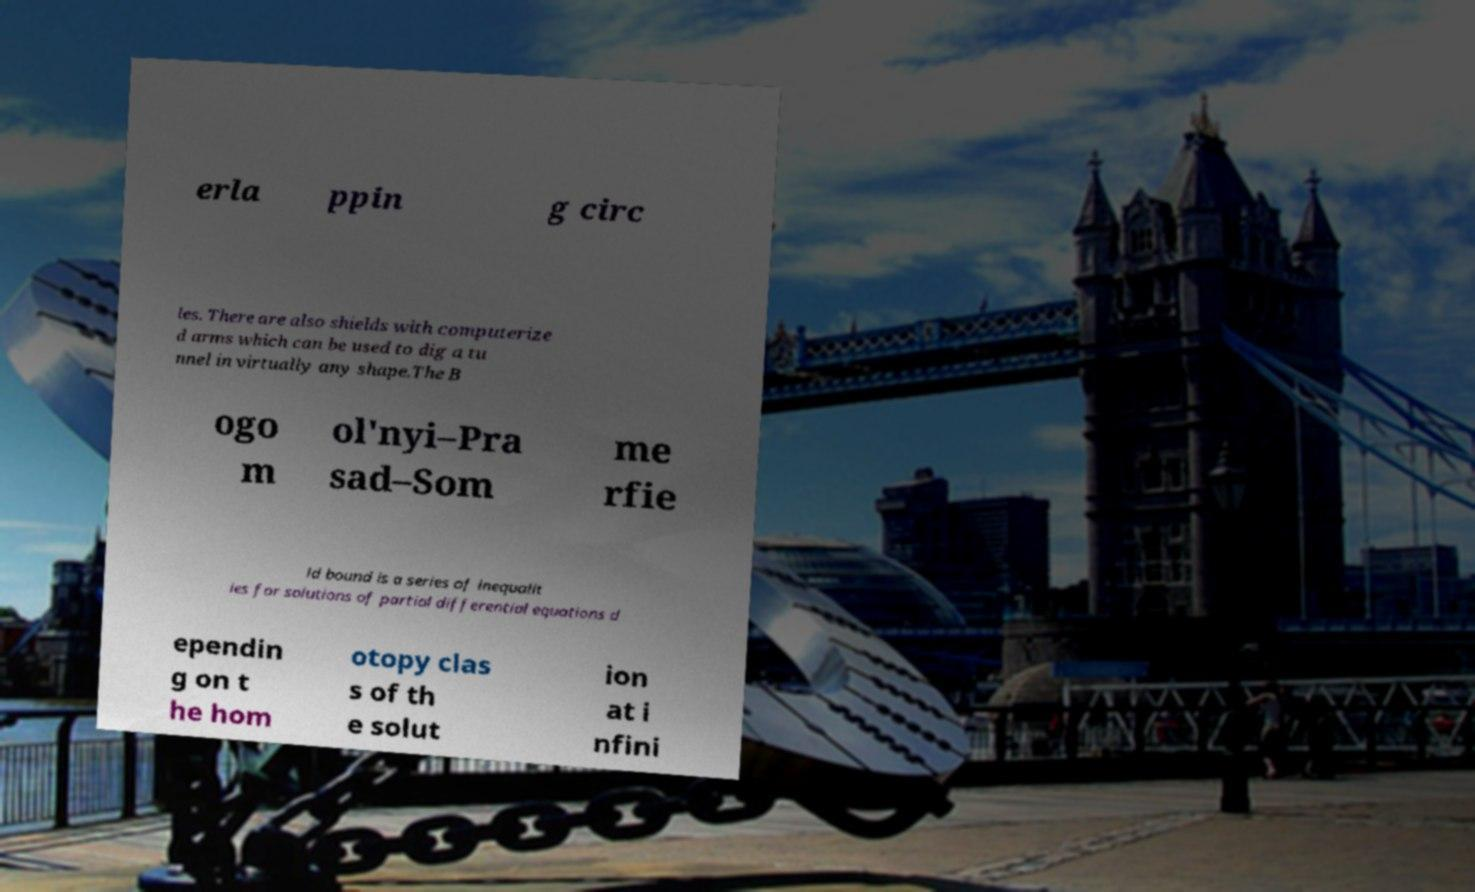For documentation purposes, I need the text within this image transcribed. Could you provide that? erla ppin g circ les. There are also shields with computerize d arms which can be used to dig a tu nnel in virtually any shape.The B ogo m ol'nyi–Pra sad–Som me rfie ld bound is a series of inequalit ies for solutions of partial differential equations d ependin g on t he hom otopy clas s of th e solut ion at i nfini 